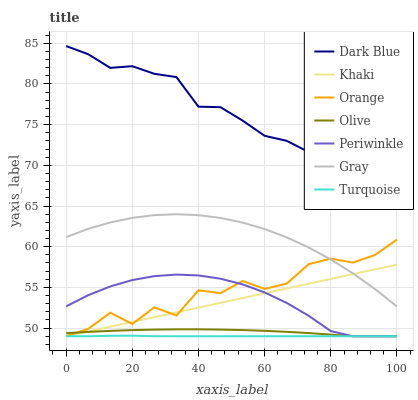Does Turquoise have the minimum area under the curve?
Answer yes or no. Yes. Does Dark Blue have the maximum area under the curve?
Answer yes or no. Yes. Does Khaki have the minimum area under the curve?
Answer yes or no. No. Does Khaki have the maximum area under the curve?
Answer yes or no. No. Is Khaki the smoothest?
Answer yes or no. Yes. Is Orange the roughest?
Answer yes or no. Yes. Is Turquoise the smoothest?
Answer yes or no. No. Is Turquoise the roughest?
Answer yes or no. No. Does Turquoise have the lowest value?
Answer yes or no. Yes. Does Dark Blue have the lowest value?
Answer yes or no. No. Does Dark Blue have the highest value?
Answer yes or no. Yes. Does Khaki have the highest value?
Answer yes or no. No. Is Olive less than Gray?
Answer yes or no. Yes. Is Dark Blue greater than Orange?
Answer yes or no. Yes. Does Turquoise intersect Orange?
Answer yes or no. Yes. Is Turquoise less than Orange?
Answer yes or no. No. Is Turquoise greater than Orange?
Answer yes or no. No. Does Olive intersect Gray?
Answer yes or no. No. 